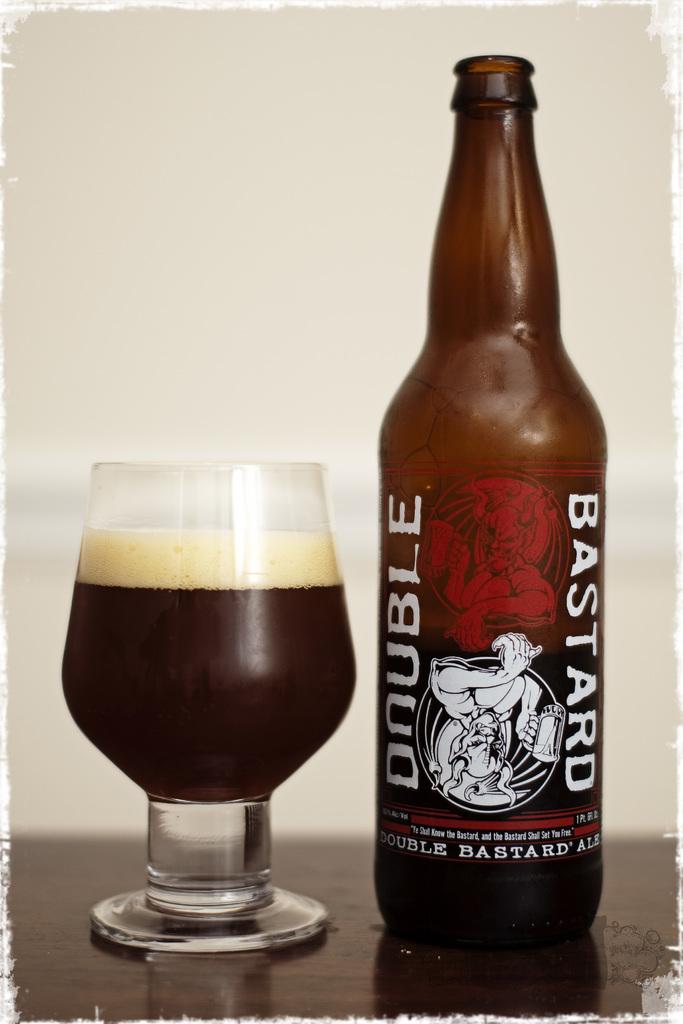What is the name of this drink?
Make the answer very short. Double bastard. Onuble bastard drink?
Your answer should be compact. Yes. 